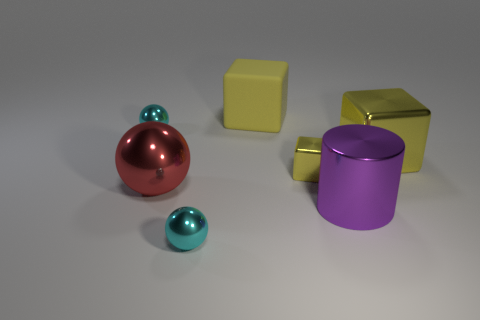There is a small yellow thing that is the same material as the purple thing; what is its shape?
Give a very brief answer. Cube. There is a small cyan thing behind the tiny cyan shiny ball that is to the right of the big red metal sphere; how many yellow cubes are in front of it?
Your response must be concise. 2. The object that is to the left of the large matte object and right of the big red thing has what shape?
Your answer should be compact. Sphere. Is the number of large yellow metallic cubes that are behind the big purple metal cylinder less than the number of large red shiny balls?
Offer a very short reply. No. What number of tiny things are either yellow matte things or yellow objects?
Give a very brief answer. 1. The rubber block is what size?
Offer a very short reply. Large. Is there anything else that has the same material as the large ball?
Ensure brevity in your answer.  Yes. How many large objects are in front of the purple cylinder?
Your answer should be very brief. 0. There is a rubber object that is the same shape as the small yellow shiny thing; what is its size?
Your answer should be very brief. Large. There is a thing that is in front of the red metal ball and left of the big purple cylinder; what size is it?
Make the answer very short. Small. 